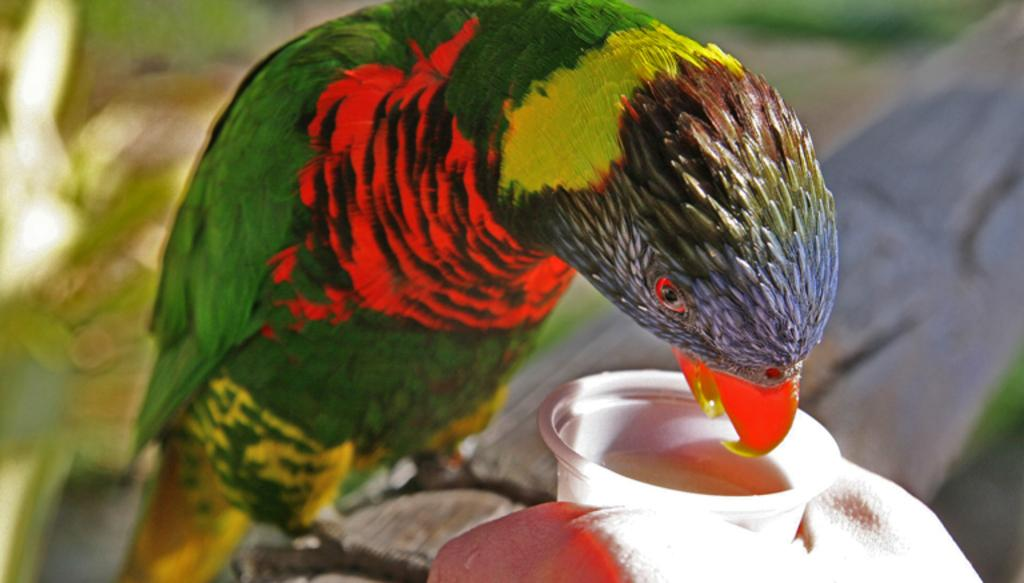What animal is in the picture? There is a parrot in the picture. Where is the parrot sitting? The parrot is sitting on a trunk. What feature is prominent on the parrot's face? The parrot has a beak. What is the person in the picture holding? The person is holding a water glass. How much does the rock weigh in the image? There is no rock present in the image, so its weight cannot be determined. 